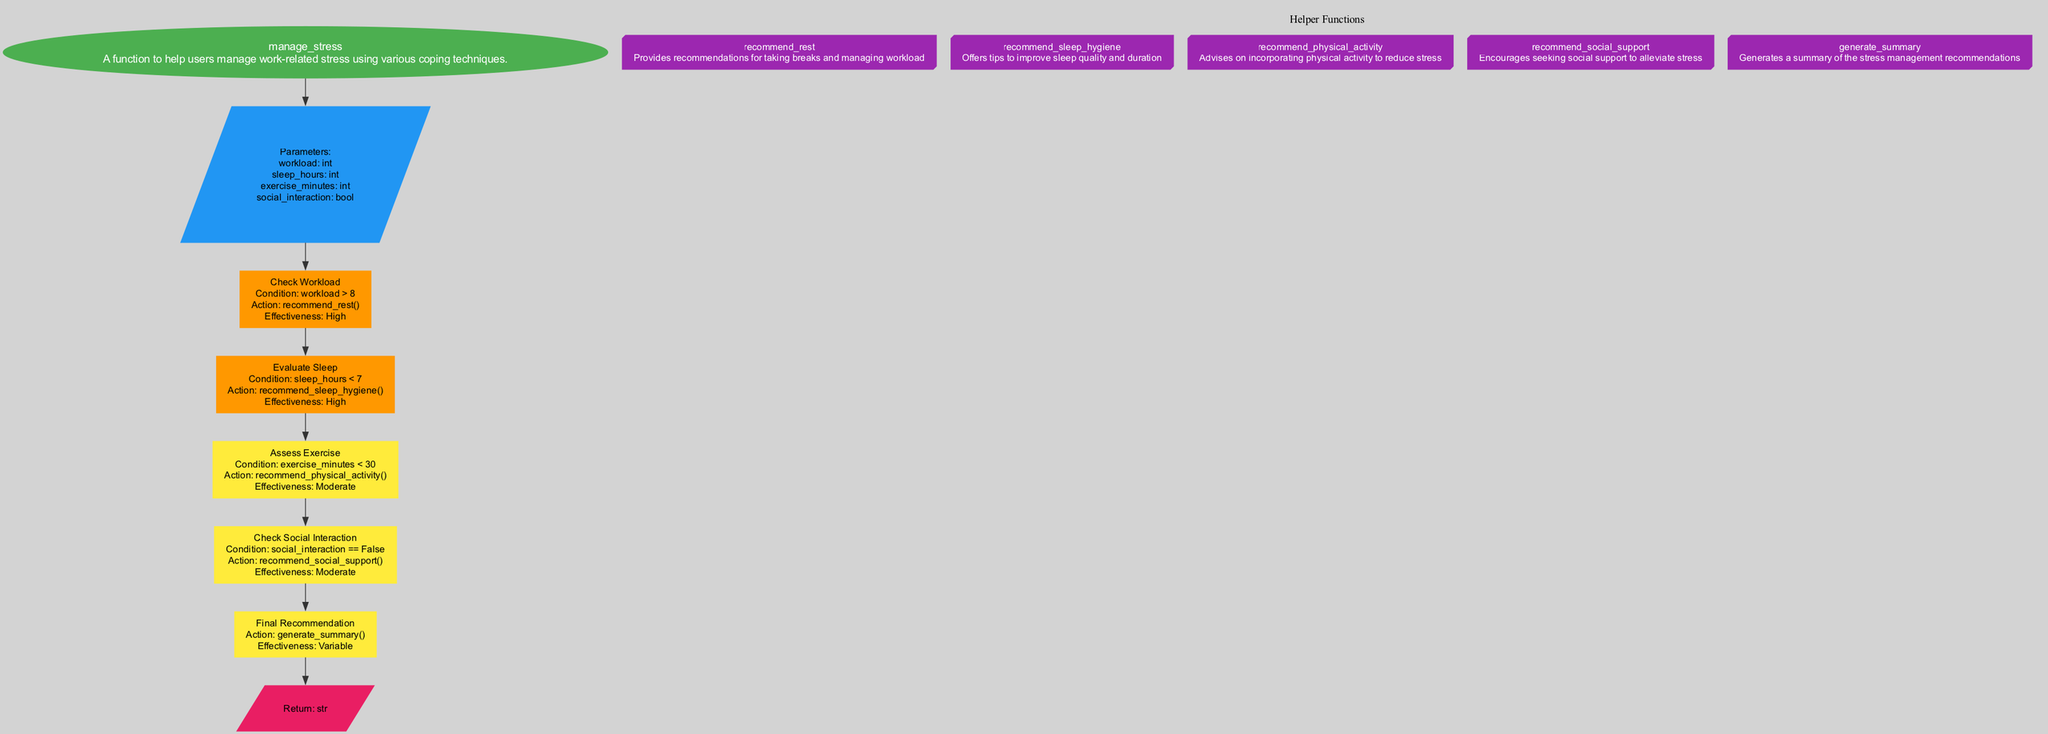What is the function name in the diagram? The function name is displayed in the oval node at the top of the diagram. It is "manage_stress".
Answer: manage_stress How many parameters does the function have? By counting the listed parameters in the parameters node, there are four parameters: workload, sleep_hours, exercise_minutes, and social_interaction.
Answer: 4 What is the effectiveness rating for the recommend_sleep_hygiene action? The effectiveness for the recommend_sleep_hygiene action can be found in the step that details evaluating sleep. The diagram states that its effectiveness is "High".
Answer: High Which step follows the check social interaction step? The step that directly follows the check social interaction step is the final recommendation step. This can be traced through the flow from the social interaction step leading to the summary generation.
Answer: Final Recommendation What action is suggested if the workload is greater than 8? The diagram specifies that if the workload is greater than 8, the action taken is to recommend rest. This corresponds with the condition in the first step of the flowchart.
Answer: recommend_rest If a user has less than 30 minutes of exercise, what is the recommended action? The diagram indicates that if exercise minutes are less than 30, the action suggested is to recommend physical activity. This is outlined in the step assessing exercise.
Answer: recommend_physical_activity What is the condition checked after evaluating sleep? After evaluating sleep, the diagram checks the condition regarding exercise minutes in the following step. This identifies if exercise minutes are less than 30.
Answer: exercise_minutes < 30 How effective is the action to recommend social support? The effectiveness of the action to recommend social support is described in its step as "Moderate". This information is noted in the details of the step that checks social interaction.
Answer: Moderate 